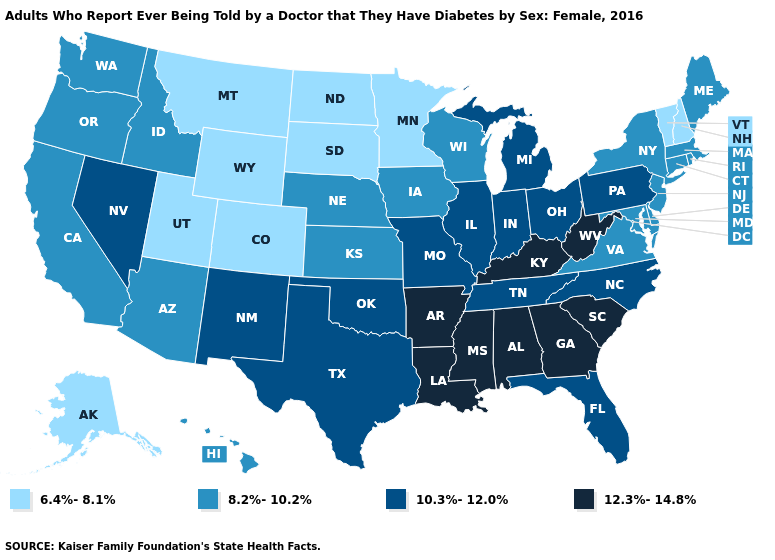What is the value of Oklahoma?
Answer briefly. 10.3%-12.0%. What is the value of Tennessee?
Keep it brief. 10.3%-12.0%. Does Illinois have a lower value than Arkansas?
Keep it brief. Yes. Among the states that border Louisiana , which have the lowest value?
Concise answer only. Texas. Does North Dakota have the lowest value in the USA?
Quick response, please. Yes. What is the lowest value in the West?
Concise answer only. 6.4%-8.1%. What is the value of Oklahoma?
Be succinct. 10.3%-12.0%. Name the states that have a value in the range 8.2%-10.2%?
Short answer required. Arizona, California, Connecticut, Delaware, Hawaii, Idaho, Iowa, Kansas, Maine, Maryland, Massachusetts, Nebraska, New Jersey, New York, Oregon, Rhode Island, Virginia, Washington, Wisconsin. Among the states that border New Hampshire , which have the highest value?
Give a very brief answer. Maine, Massachusetts. What is the value of Ohio?
Answer briefly. 10.3%-12.0%. What is the lowest value in the USA?
Quick response, please. 6.4%-8.1%. What is the value of Wisconsin?
Quick response, please. 8.2%-10.2%. What is the value of Indiana?
Short answer required. 10.3%-12.0%. Name the states that have a value in the range 8.2%-10.2%?
Concise answer only. Arizona, California, Connecticut, Delaware, Hawaii, Idaho, Iowa, Kansas, Maine, Maryland, Massachusetts, Nebraska, New Jersey, New York, Oregon, Rhode Island, Virginia, Washington, Wisconsin. What is the value of Virginia?
Concise answer only. 8.2%-10.2%. 